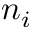Convert formula to latex. <formula><loc_0><loc_0><loc_500><loc_500>n _ { i }</formula> 